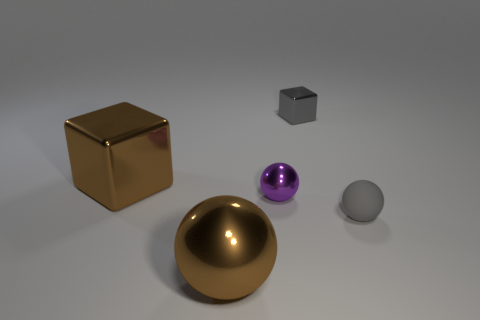What number of matte things are on the left side of the metallic ball to the right of the big brown shiny sphere?
Provide a succinct answer. 0. There is a small thing that is made of the same material as the tiny gray block; what is its shape?
Your response must be concise. Sphere. What number of purple things are small rubber balls or small matte cylinders?
Keep it short and to the point. 0. There is a large brown ball that is in front of the cube that is to the left of the small cube; are there any tiny blocks on the left side of it?
Provide a short and direct response. No. Are there fewer purple cylinders than gray spheres?
Offer a terse response. Yes. Is the shape of the big brown object left of the brown metal sphere the same as  the tiny rubber thing?
Keep it short and to the point. No. Are there any brown metallic objects?
Keep it short and to the point. Yes. What color is the small object that is to the right of the metal block that is behind the shiny cube left of the tiny purple shiny ball?
Ensure brevity in your answer.  Gray. Are there the same number of tiny metal objects that are on the left side of the small gray cube and small gray metallic things on the left side of the tiny purple metallic ball?
Offer a very short reply. No. The matte object that is the same size as the purple metal thing is what shape?
Provide a short and direct response. Sphere. 